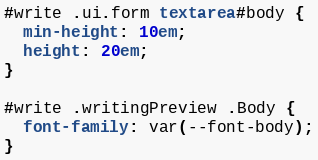Convert code to text. <code><loc_0><loc_0><loc_500><loc_500><_CSS_>
#write .ui.form textarea#body {
  min-height: 10em;
  height: 20em;
}

#write .writingPreview .Body {
  font-family: var(--font-body);
}
</code> 